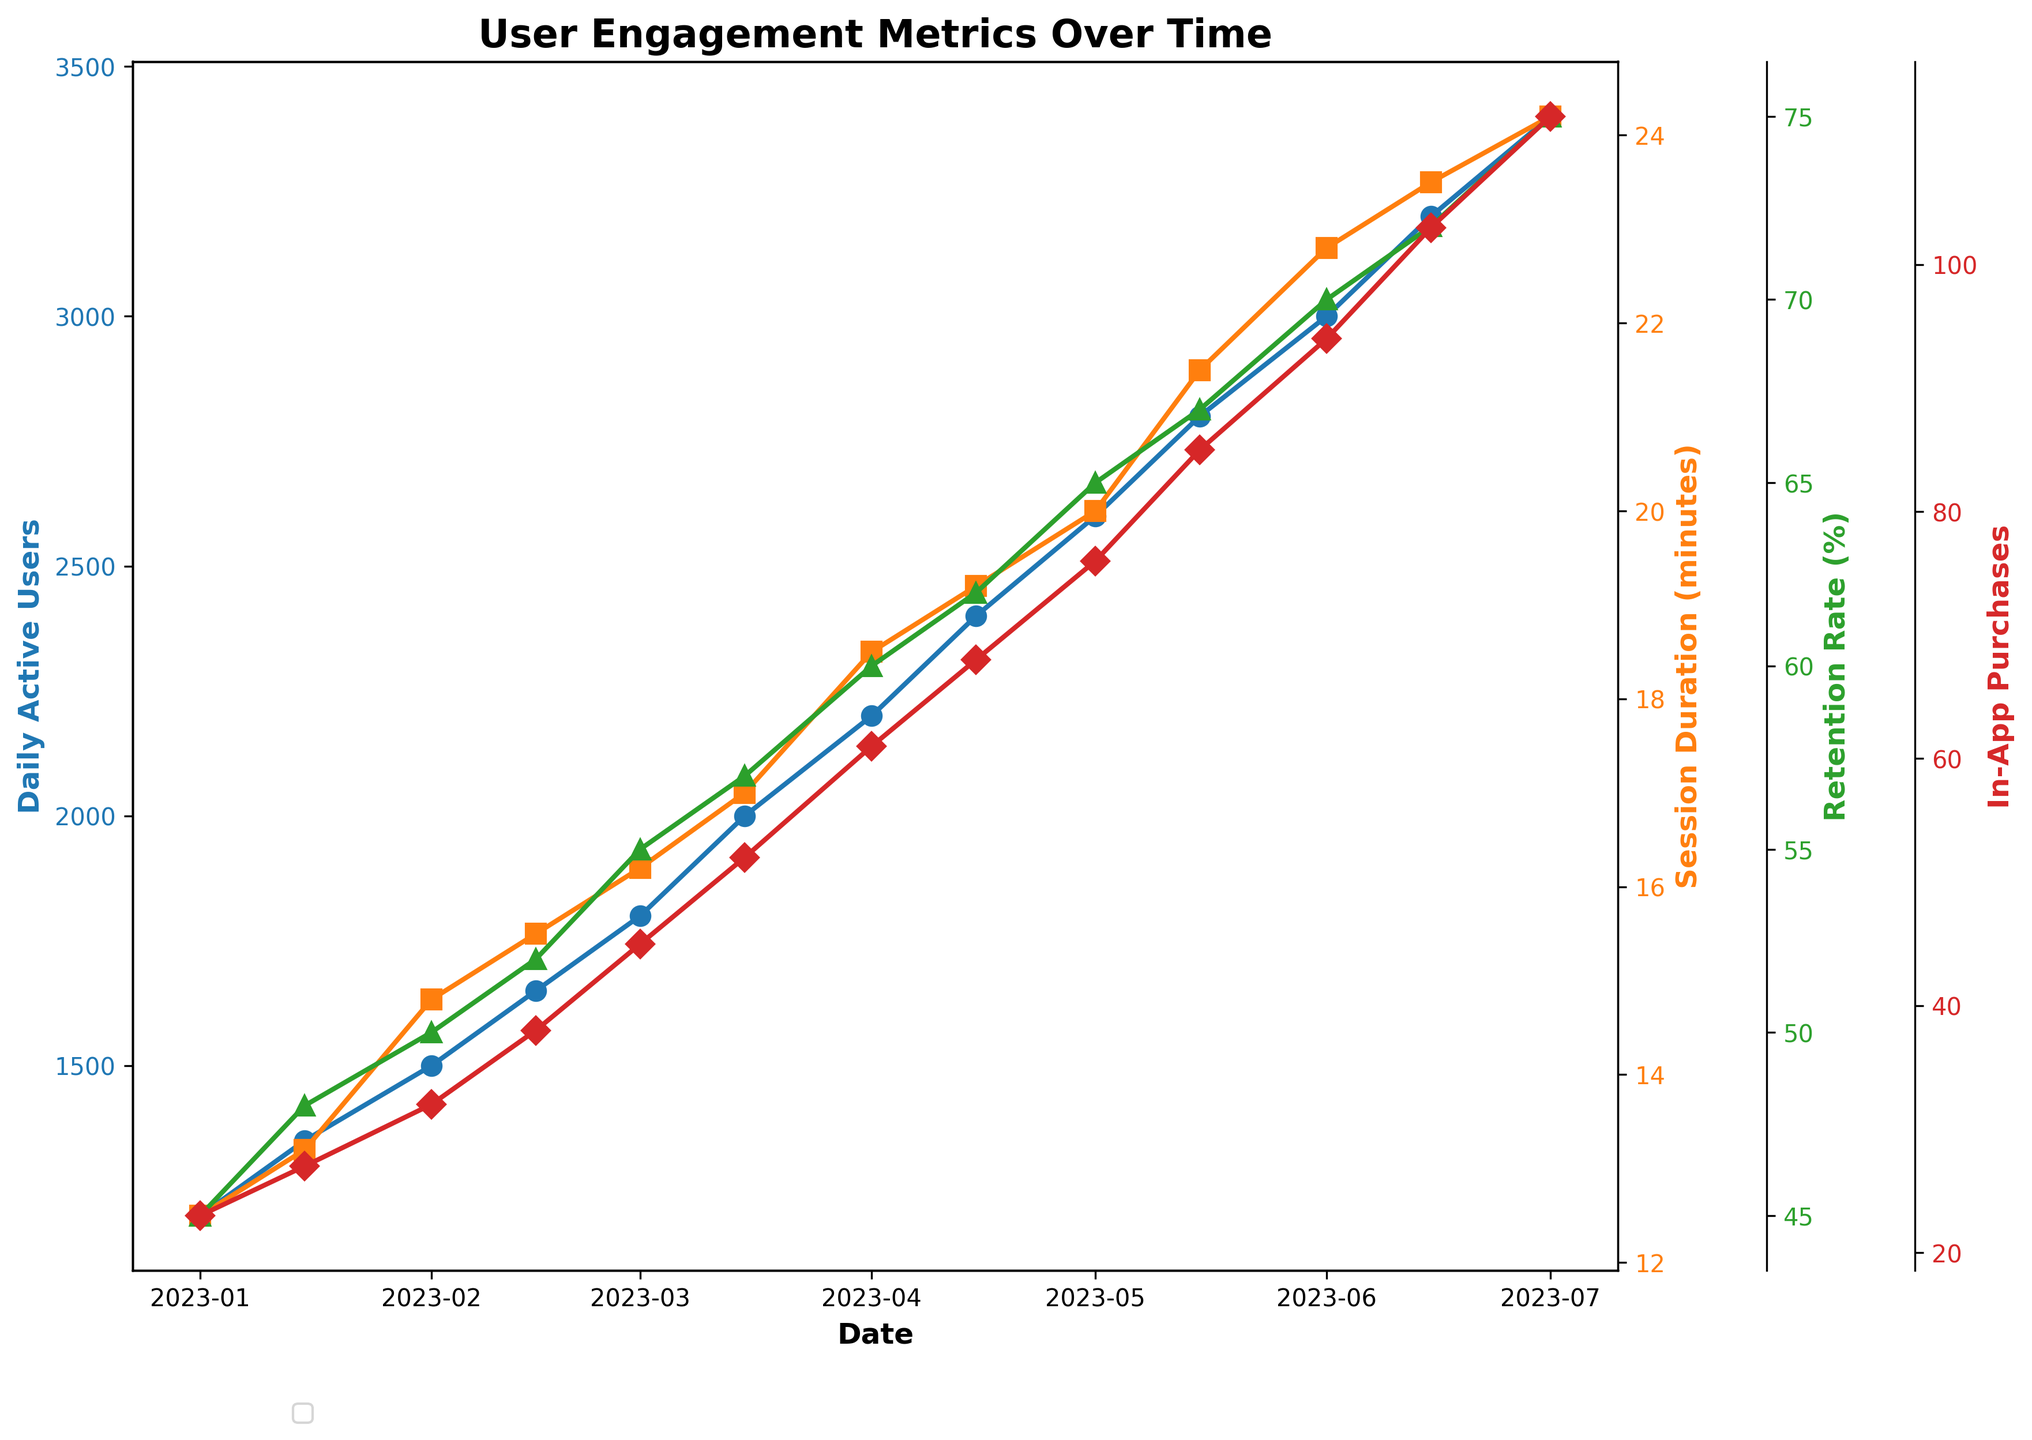What is the overall trend in Daily Active Users after January 2023? Over time, the number of Daily Active Users shows a consistent increase from 1200 in January 2023 to 3400 in July 2023.
Answer: Increasing Which metric consistently shows the highest values throughout the timeline? By comparing the lines, the Daily Active Users consistently show higher values than Session Duration, Retention Rate, and In-App Purchases across all time points.
Answer: Daily Active Users On which date did Daily Active Users first reach 2000? The line for Daily Active Users first reaches 2000 on March 15, 2023.
Answer: March 15, 2023 What was the Session Duration (in minutes) when the Retention Rate was at 55%? When the Retention Rate was 55% on March 1, 2023, the Session Duration was 16.2 minutes.
Answer: 16.2 minutes Calculate the total increase in In-App Purchases from January 1, 2023, to July 1, 2023. Initial In-App Purchases on January 1, 2023, were 23, and on July 1, 2023, they were 112. The total increase is 112 - 23 = 89.
Answer: 89 What is the difference in the Session Duration between February 1 and June 1, 2023? Session Duration on February 1, 2023, was 14.8 minutes, and on June 1, 2023, it was 22.8 minutes. The difference is 22.8 - 14.8 = 8 minutes.
Answer: 8 minutes How does the Retention Rate on May 1, 2023, compare to April 1, 2023? On May 1, 2023, the Retention Rate was 65%, while on April 1, 2023, it was 60%. The May rate is higher.
Answer: Higher Which metric saw the highest percentage increase from January 1, 2023, to July 1, 2023? Calculating the percentage increase for each metric:
Daily Active Users: (3400-1200)/1200 * 100 = 183.33%
Session Duration: (24.2-12.5)/12.5 * 100 = 93.6%
Retention Rate: (75-45)/45 * 100 = 66.67%
In-App Purchases: (112-23)/23 * 100 = 386.96%
In-App Purchases saw the highest percentage increase.
Answer: In-App Purchases Identify the two dates that show the largest increment in Daily Active Users. The largest increment is between consecutive dates: June 15, 2023, (3200) and July 1, 2023, (3400). The increment is 200.
Answer: June 15, 2023, and July 1, 2023 